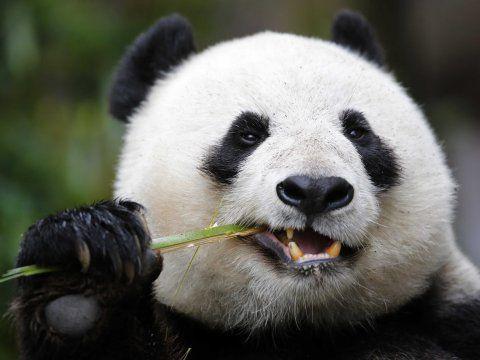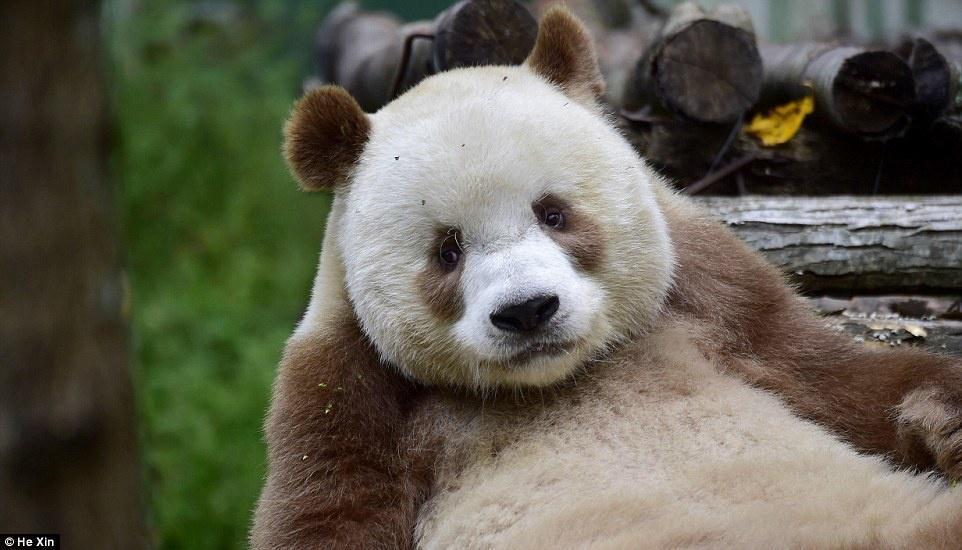The first image is the image on the left, the second image is the image on the right. Examine the images to the left and right. Is the description "An image shows two pandas in close contact." accurate? Answer yes or no. No. The first image is the image on the left, the second image is the image on the right. Examine the images to the left and right. Is the description "The panda in at least one of the images is holding a bamboo shoot." accurate? Answer yes or no. Yes. 